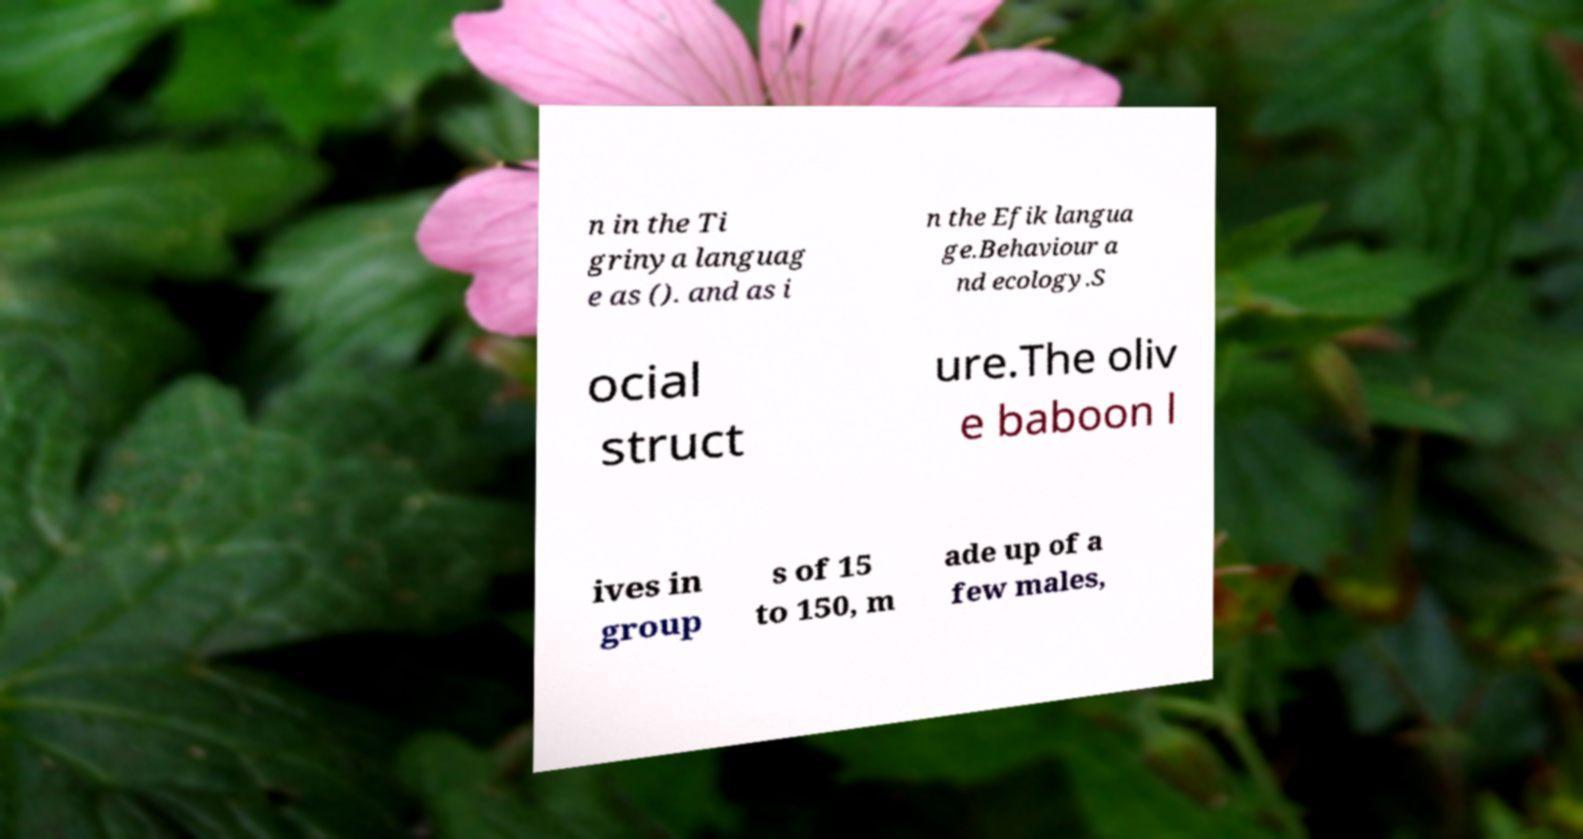Could you assist in decoding the text presented in this image and type it out clearly? n in the Ti grinya languag e as (). and as i n the Efik langua ge.Behaviour a nd ecology.S ocial struct ure.The oliv e baboon l ives in group s of 15 to 150, m ade up of a few males, 